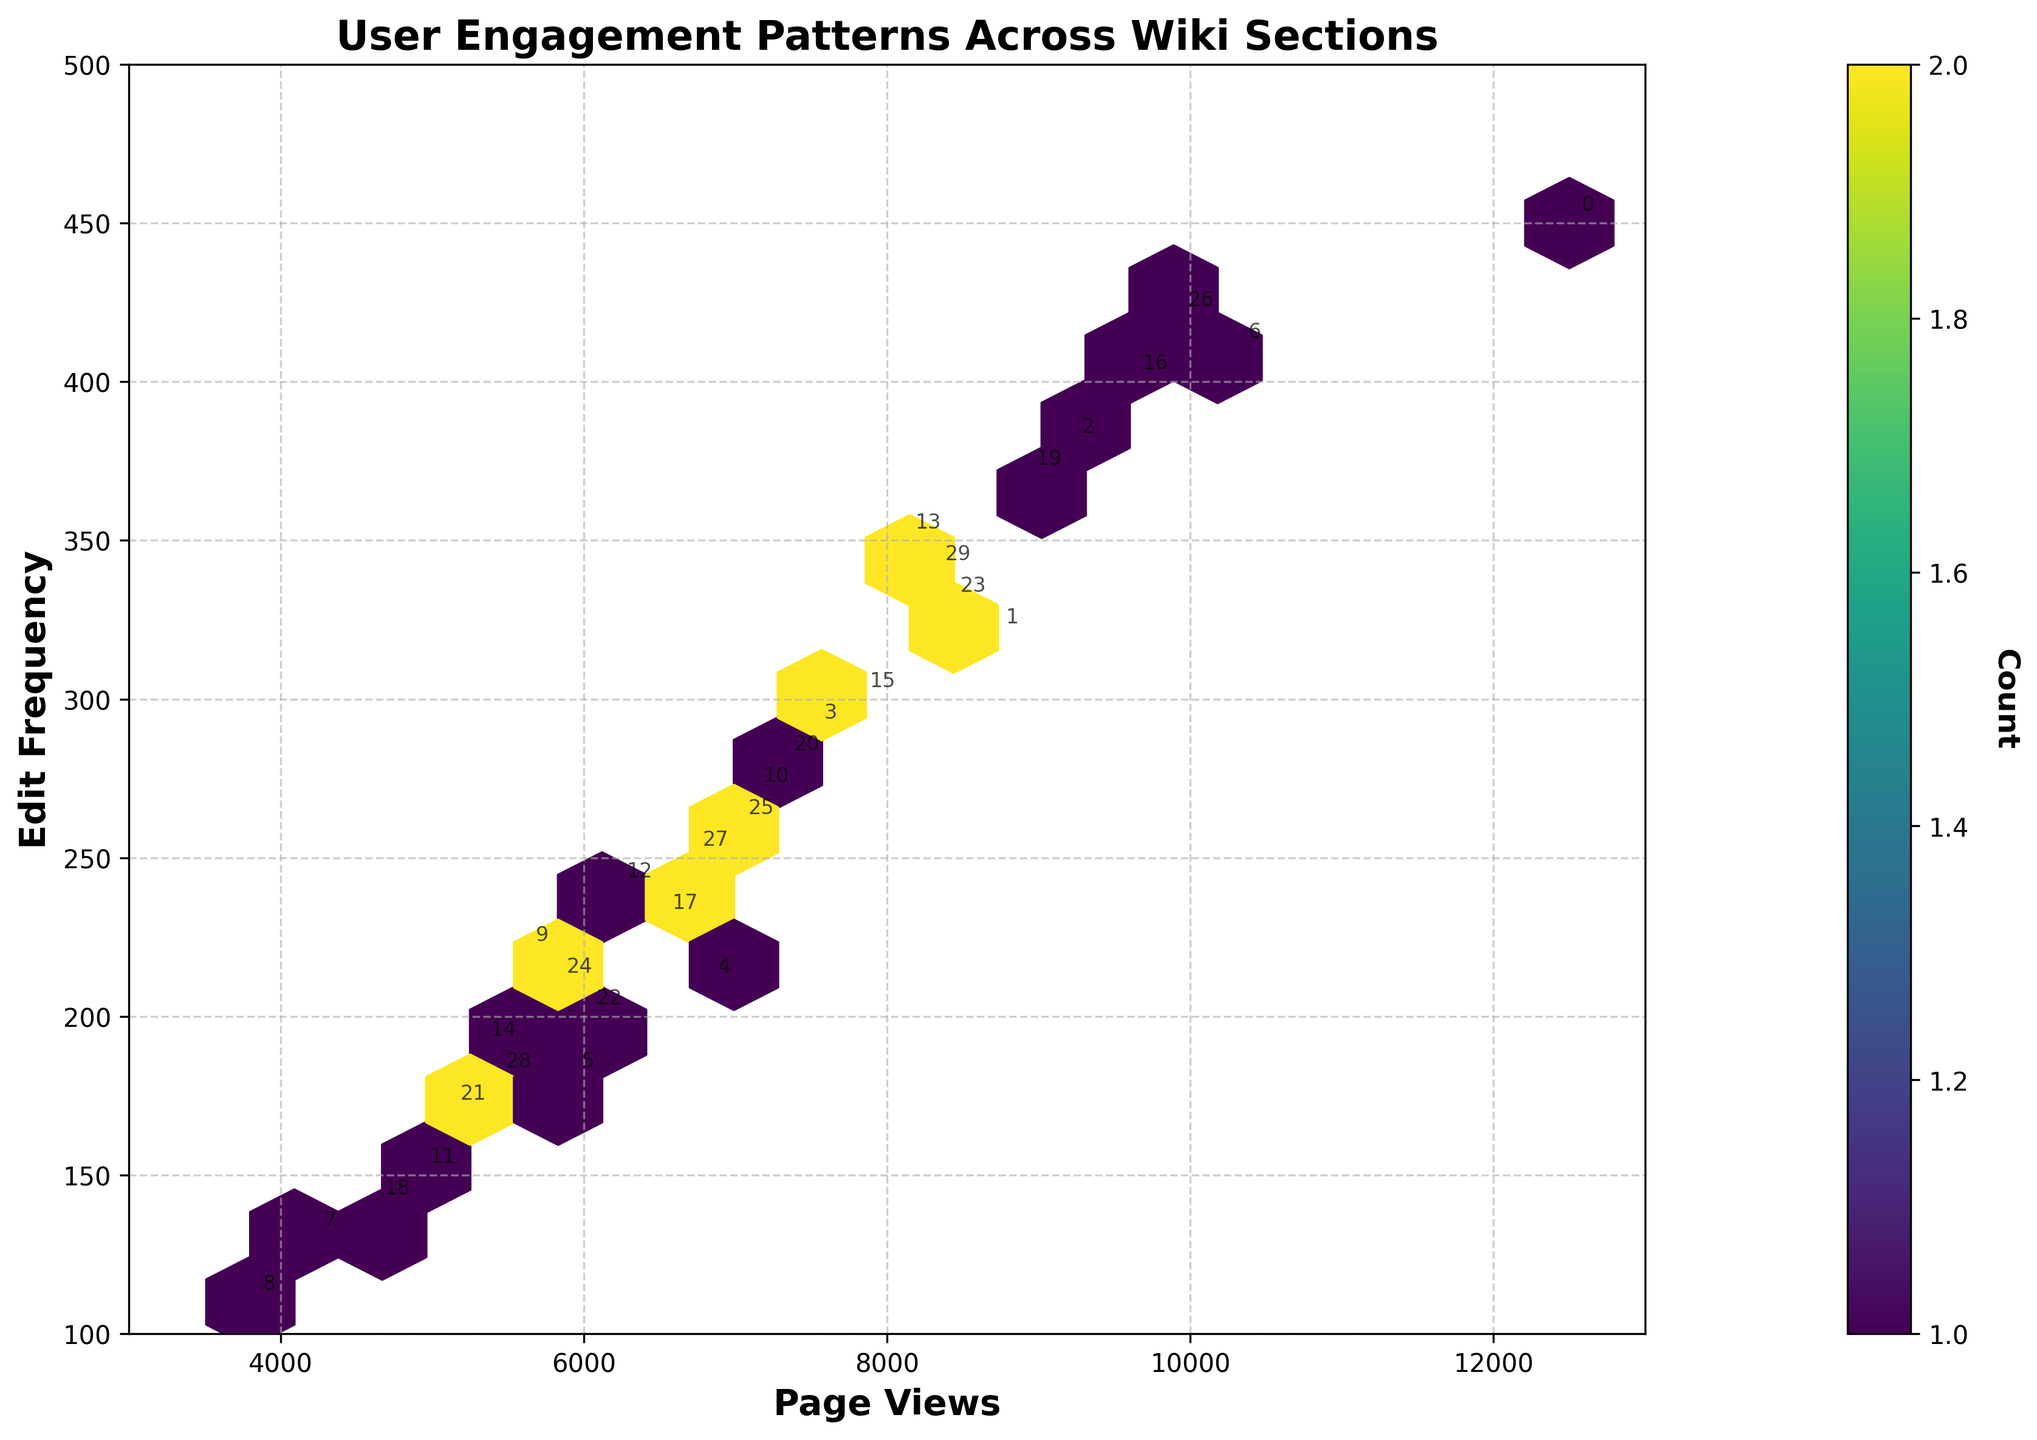What is the title of the Hexbin Plot? The title of the Hexbin Plot is located at the top of the figure. It explicitly states the topic being visualized.
Answer: User Engagement Patterns Across Wiki Sections What are the labels of the x-axis and y-axis? The labels of the axes are provided adjacent to the respective axes. The x-axis represents 'Page Views' and the y-axis represents 'Edit Frequency'.
Answer: Page Views and Edit Frequency Which section has the highest page views? By examining the Hexbin Plot, locate the point furthest to the right on the x-axis to find the section with the highest page views, which is the 'Main Page' with 12,500 page views.
Answer: Main Page Which section has the highest edit frequency? By examining the Hexbin Plot, locate the point highest on the y-axis. The point located at the top corresponds to the 'Main Page' with 450 edits.
Answer: Main Page How many color-coded hexagon bins are in the plot? Count the number of individual hexagon shapes visible on the plot.
Answer: 15 (or a specific number relevant to the grid) How does the relationship between page views and edit frequency appear overall? By analyzing the Hexbin Plot, we can determine the overall trend. Typically, a positive correlation indicates that as page views increase, edit frequency also tends to increase.
Answer: Positive Correlation How are sections like 'Current Events' and 'Business' positioned in terms of user engagement? Locate 'Current Events' and 'Business' on the Hexbin Plot to find their page view and edit frequency values. 'Current Events' has 10,300 page views and 410 edits, while 'Business' has 9,600 page views and 400 edits. Both are positioned high in terms of user engagement with high page views and edit frequencies.
Answer: High Engagement Which section has relatively low page views and low edit frequency? Identify the section positioned towards both the lower left of the Hexbin Plot. 'Philosophy' with 3,800 page views and 110 edits fits this criterion.
Answer: Philosophy Compare the user engagement between 'Sports' and 'Arts'. Which has higher engagement? Locate the points for 'Sports' and 'Arts' on the plot. 'Sports' has 4,200 page views and 130 edit frequency, whereas 'Arts' has 6,800 page views and 210 edit frequency. 'Arts' has higher engagement.
Answer: Arts Are there any clusters, and what might they represent in terms of user engagement? The density of hexagons in certain areas indicates the concentration of sections with similar levels of user engagement. A prominent cluster suggests many sections have moderate page views and edit frequencies, indicating balanced user interest across those sections.
Answer: Cluster with moderate engagement 